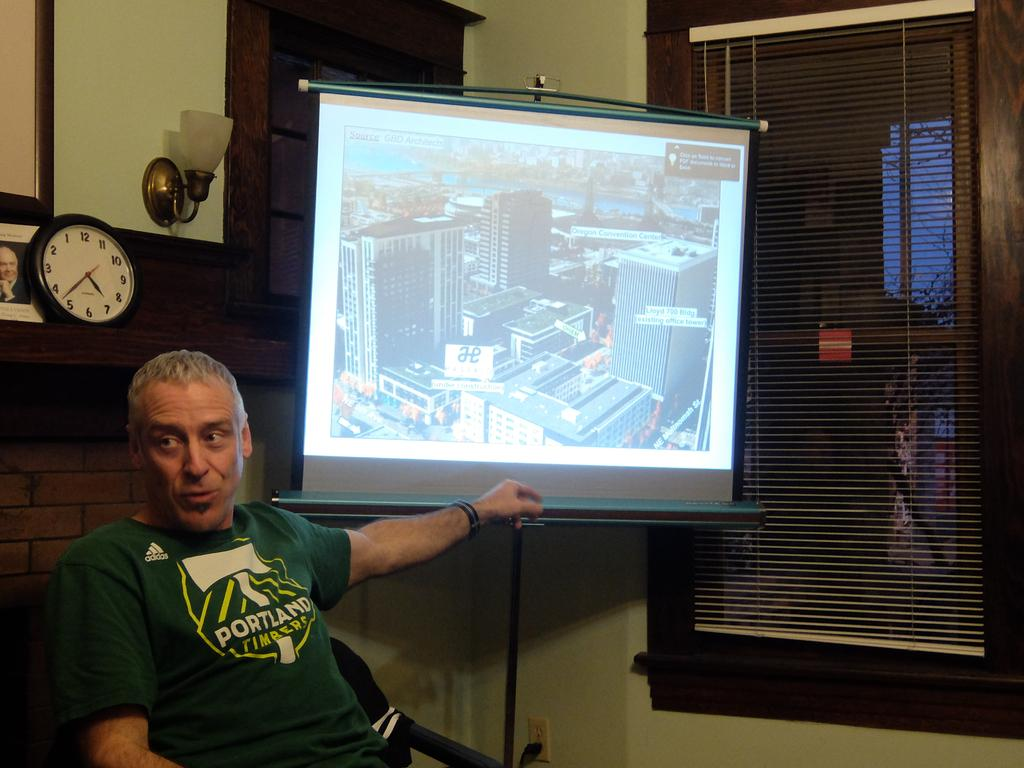Provide a one-sentence caption for the provided image. A man in a Portland t-shirt sits near a projection screen and a clock. 